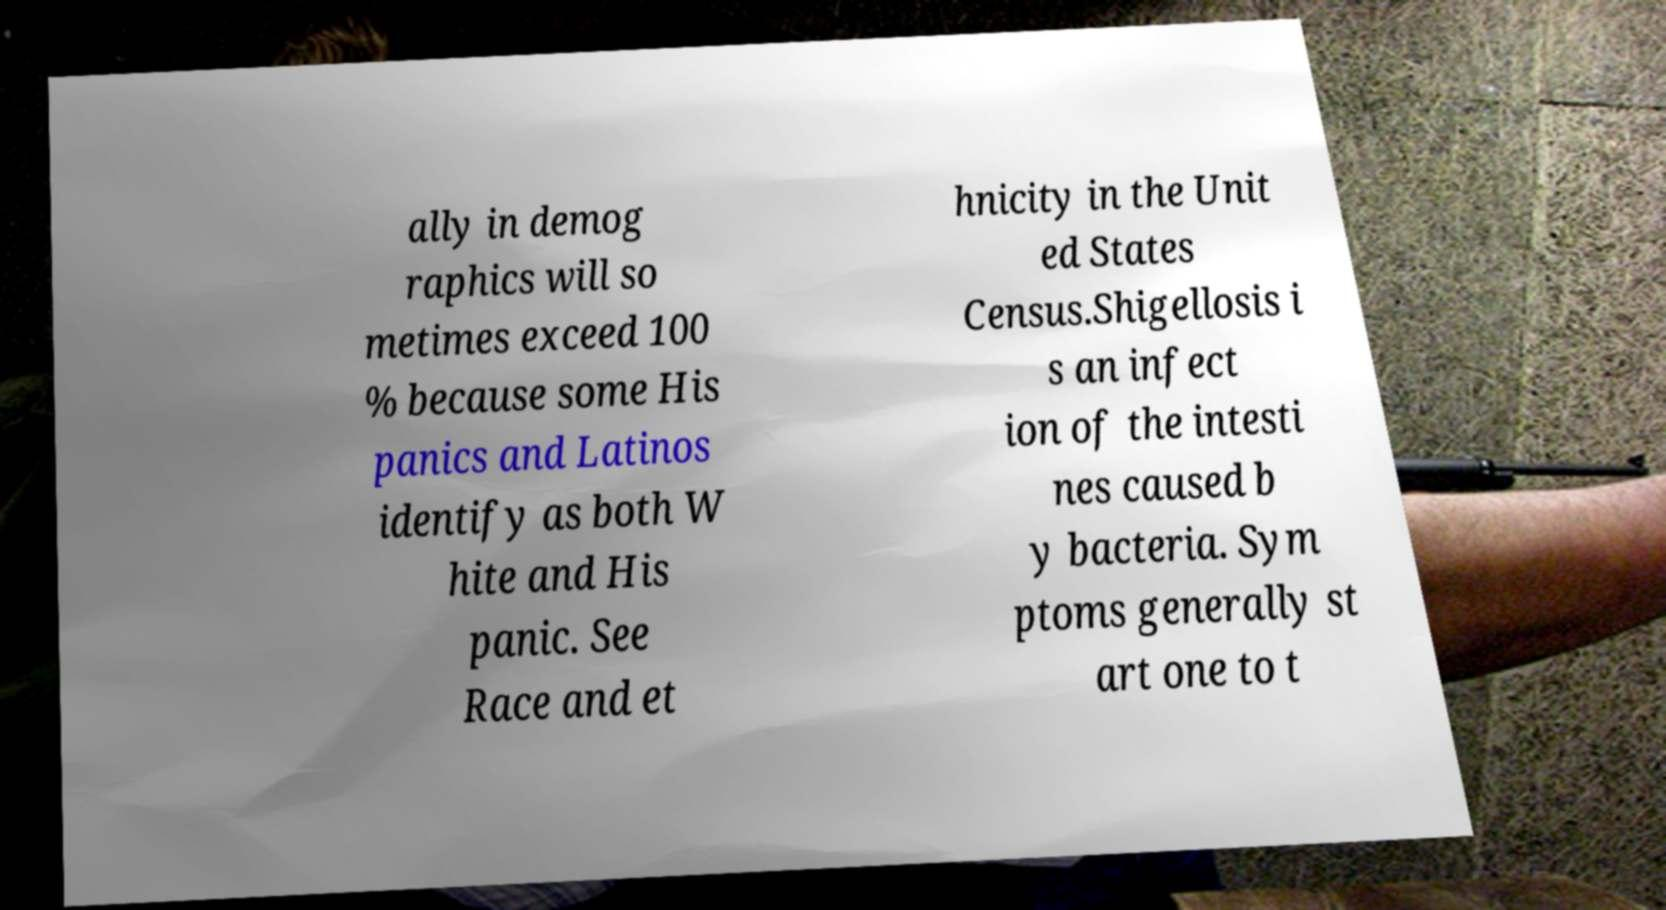Can you accurately transcribe the text from the provided image for me? ally in demog raphics will so metimes exceed 100 % because some His panics and Latinos identify as both W hite and His panic. See Race and et hnicity in the Unit ed States Census.Shigellosis i s an infect ion of the intesti nes caused b y bacteria. Sym ptoms generally st art one to t 